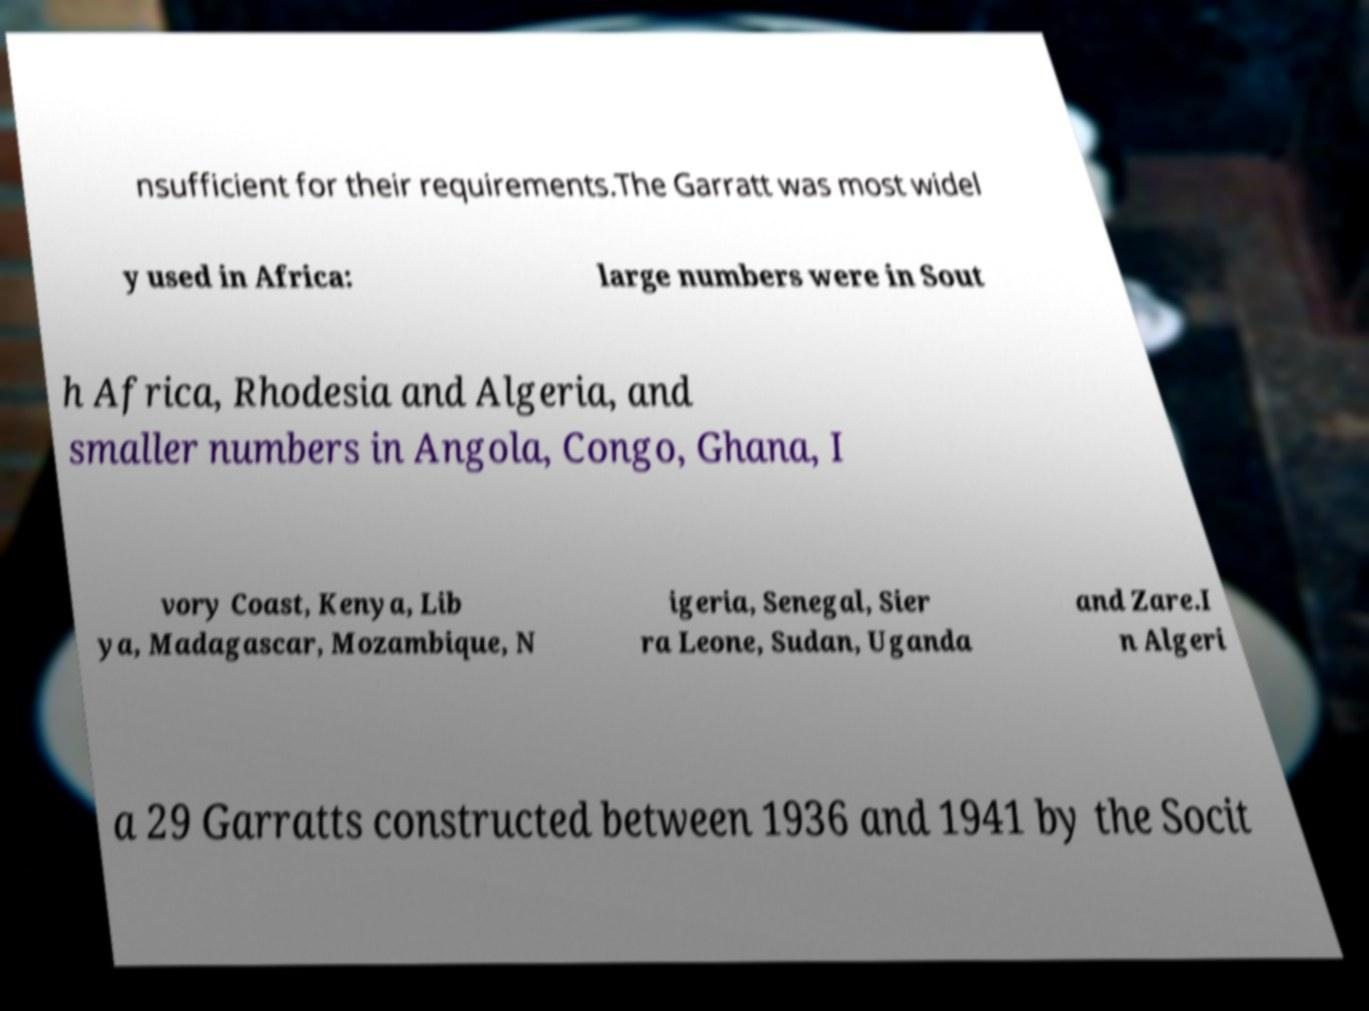Please read and relay the text visible in this image. What does it say? nsufficient for their requirements.The Garratt was most widel y used in Africa: large numbers were in Sout h Africa, Rhodesia and Algeria, and smaller numbers in Angola, Congo, Ghana, I vory Coast, Kenya, Lib ya, Madagascar, Mozambique, N igeria, Senegal, Sier ra Leone, Sudan, Uganda and Zare.I n Algeri a 29 Garratts constructed between 1936 and 1941 by the Socit 